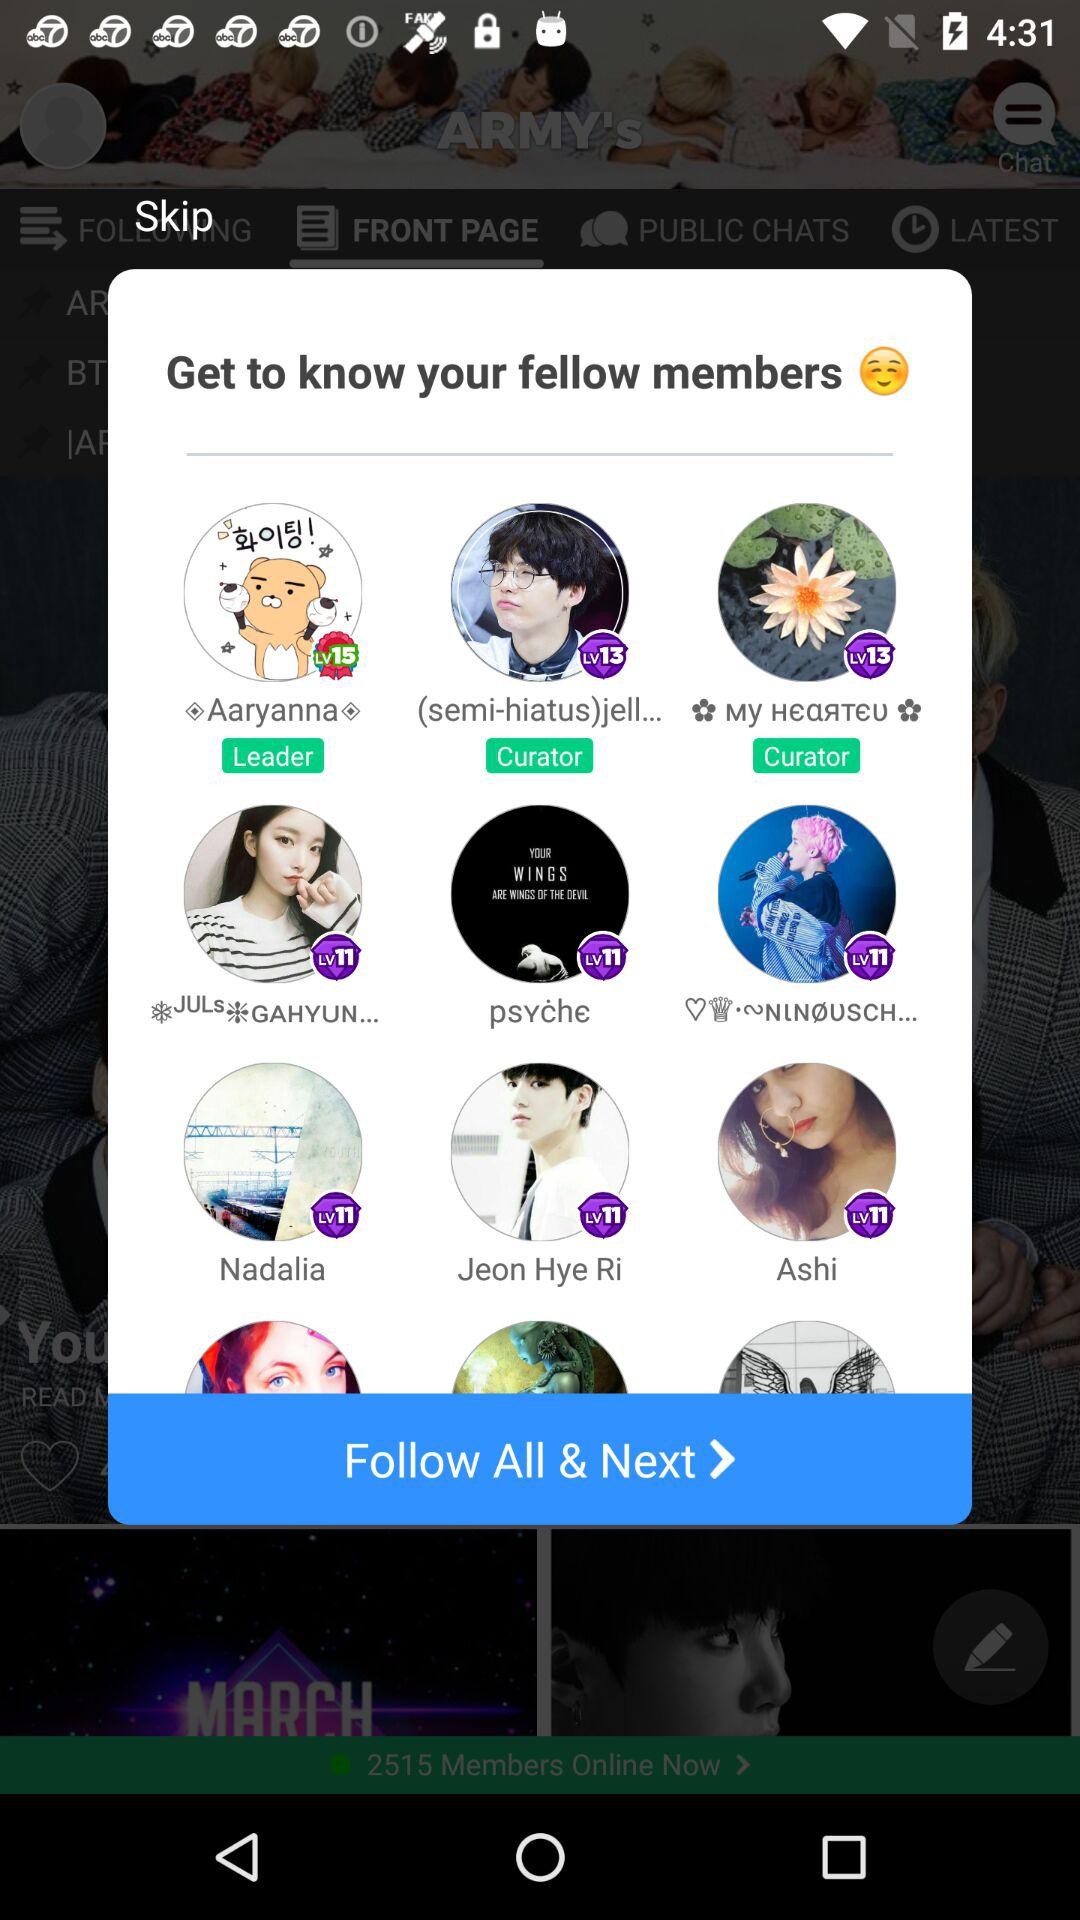Who is the leader? The leader is Aaryanna. 